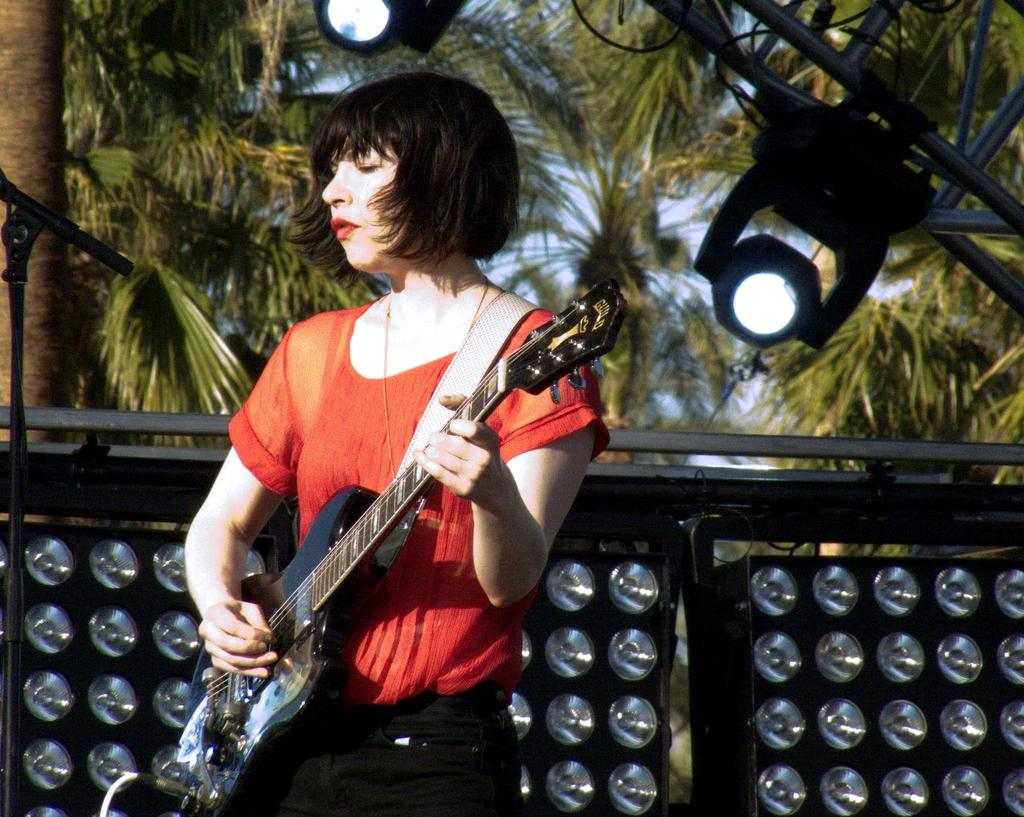Who is the main subject in the image? There is a woman in the image. What is the woman wearing? The woman is wearing a red t-shirt. What is the woman doing in the image? The woman is playing the guitar. What can be seen in the background of the image? There are lights and trees in the background of the image. What type of calculator is the woman using in the image? There is no calculator present in the image; the woman is playing the guitar. What activity is the woman engaged in with the need? The provided facts do not mention a need or any activity related to it, so we cannot answer this question. 